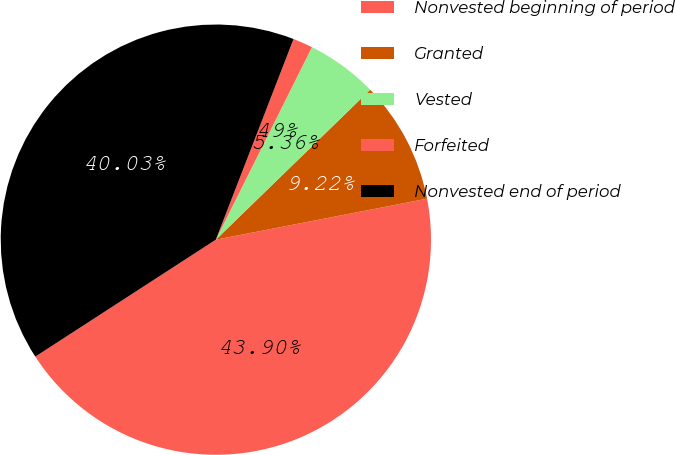Convert chart to OTSL. <chart><loc_0><loc_0><loc_500><loc_500><pie_chart><fcel>Nonvested beginning of period<fcel>Granted<fcel>Vested<fcel>Forfeited<fcel>Nonvested end of period<nl><fcel>43.9%<fcel>9.22%<fcel>5.36%<fcel>1.49%<fcel>40.03%<nl></chart> 